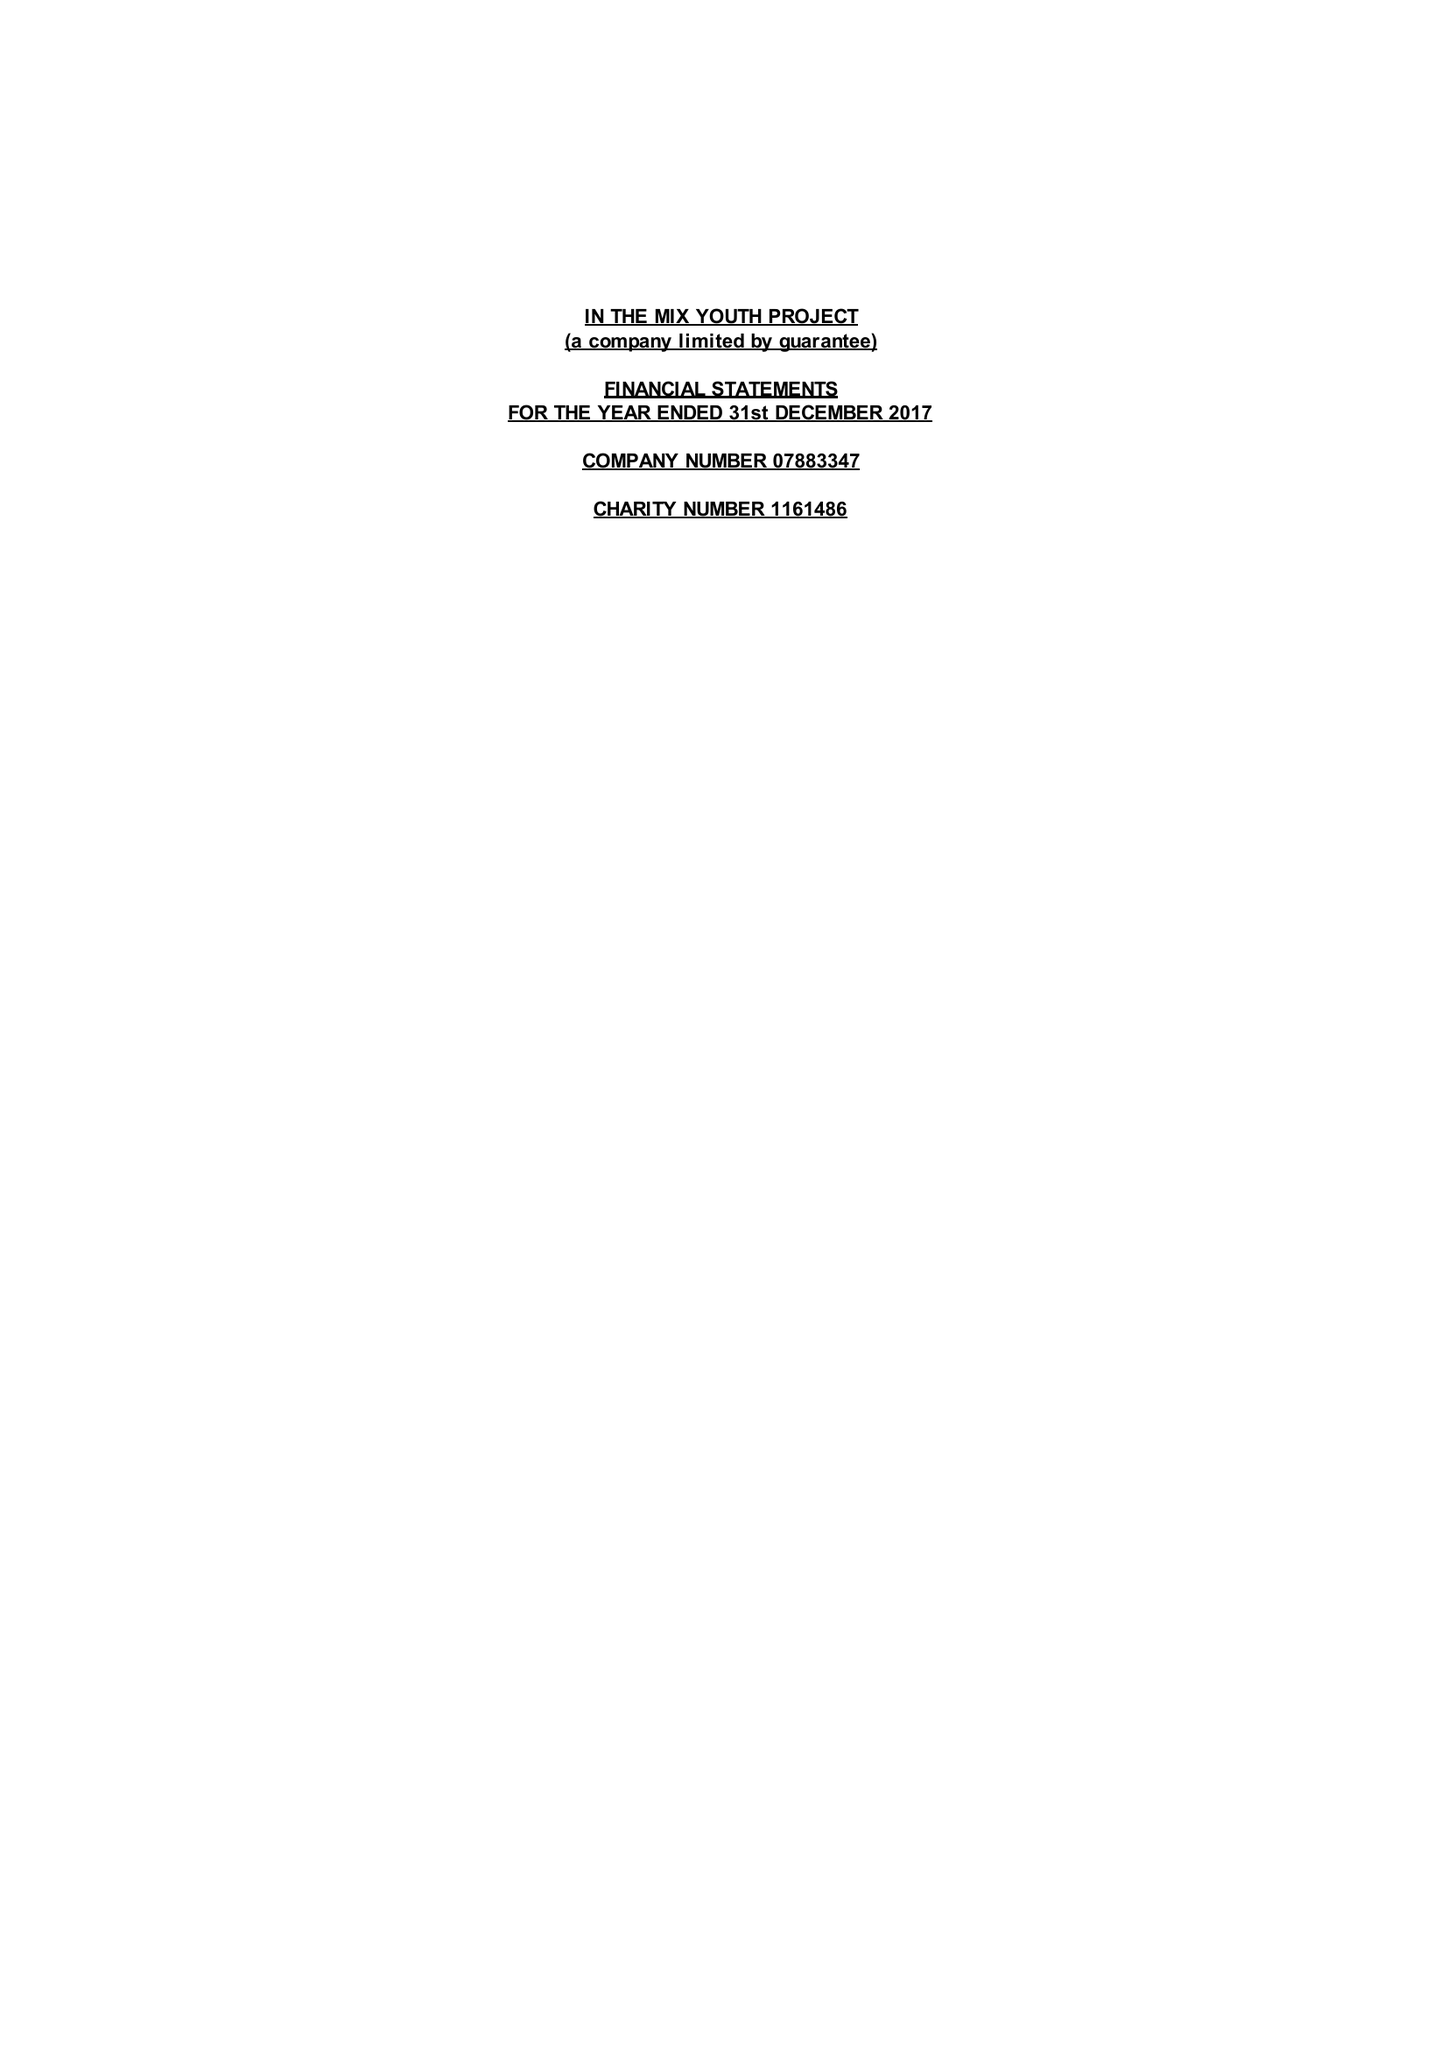What is the value for the spending_annually_in_british_pounds?
Answer the question using a single word or phrase. 54014.00 